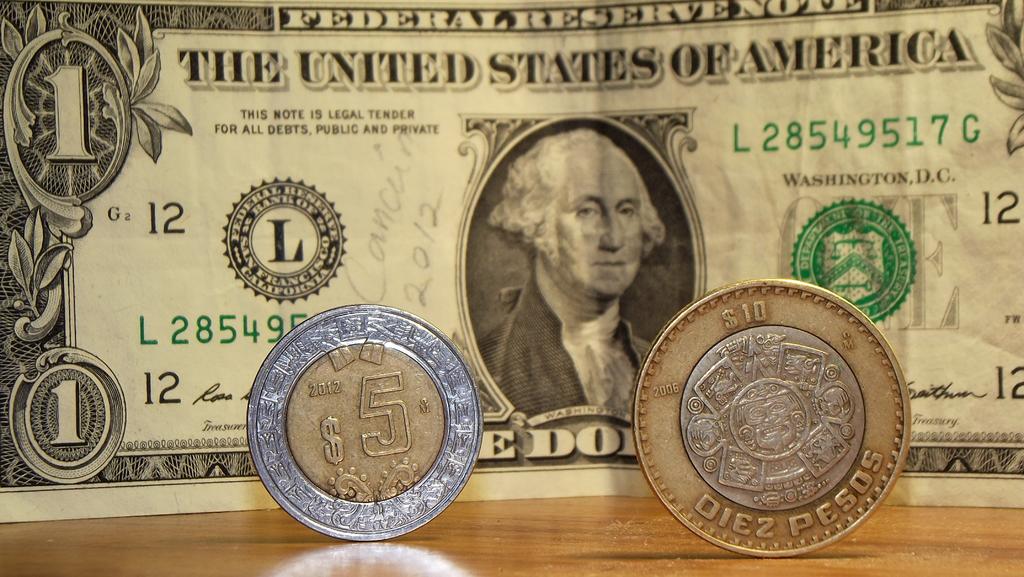How much could that be in total?
Offer a very short reply. $16. What year is hand written on the dollar bill?
Give a very brief answer. 2012. 